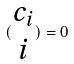<formula> <loc_0><loc_0><loc_500><loc_500>( \begin{matrix} c _ { i } \\ i \end{matrix} ) = 0</formula> 